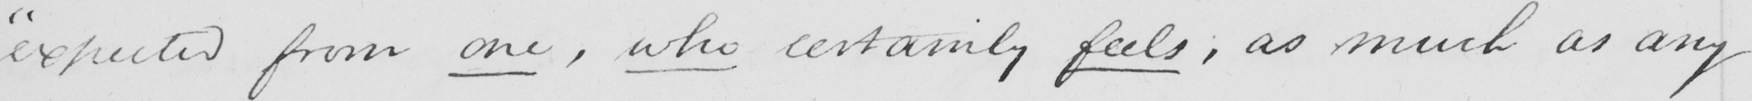Please transcribe the handwritten text in this image. " expected from one , who certainly feels , as much as any 